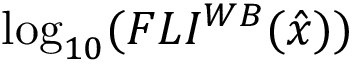Convert formula to latex. <formula><loc_0><loc_0><loc_500><loc_500>\log _ { 1 0 } ( F L I ^ { W B } ( \hat { x } ) )</formula> 